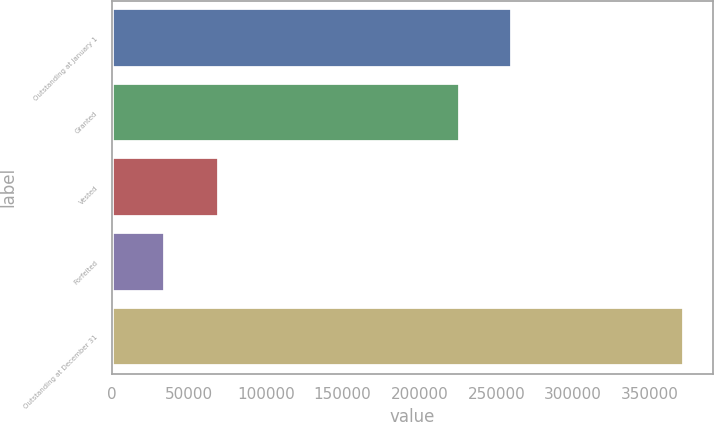Convert chart. <chart><loc_0><loc_0><loc_500><loc_500><bar_chart><fcel>Outstanding at January 1<fcel>Granted<fcel>Vested<fcel>Forfeited<fcel>Outstanding at December 31<nl><fcel>260495<fcel>226700<fcel>69872<fcel>34500<fcel>372453<nl></chart> 